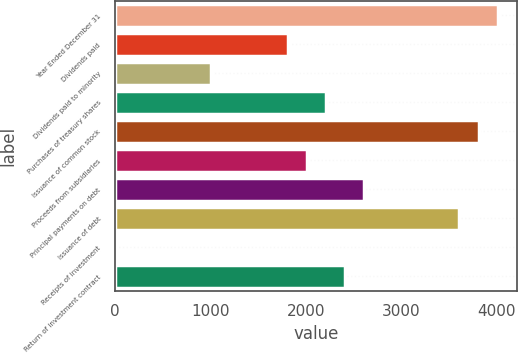<chart> <loc_0><loc_0><loc_500><loc_500><bar_chart><fcel>Year Ended December 31<fcel>Dividends paid<fcel>Dividends paid to minority<fcel>Purchases of treasury shares<fcel>Issuance of common stock<fcel>Proceeds from subsidiaries<fcel>Principal payments on debt<fcel>Issuance of debt<fcel>Receipts of investment<fcel>Return of investment contract<nl><fcel>4008<fcel>1805.8<fcel>1005<fcel>2206.2<fcel>3807.8<fcel>2006<fcel>2606.6<fcel>3607.6<fcel>4<fcel>2406.4<nl></chart> 